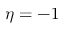<formula> <loc_0><loc_0><loc_500><loc_500>\eta = - 1</formula> 